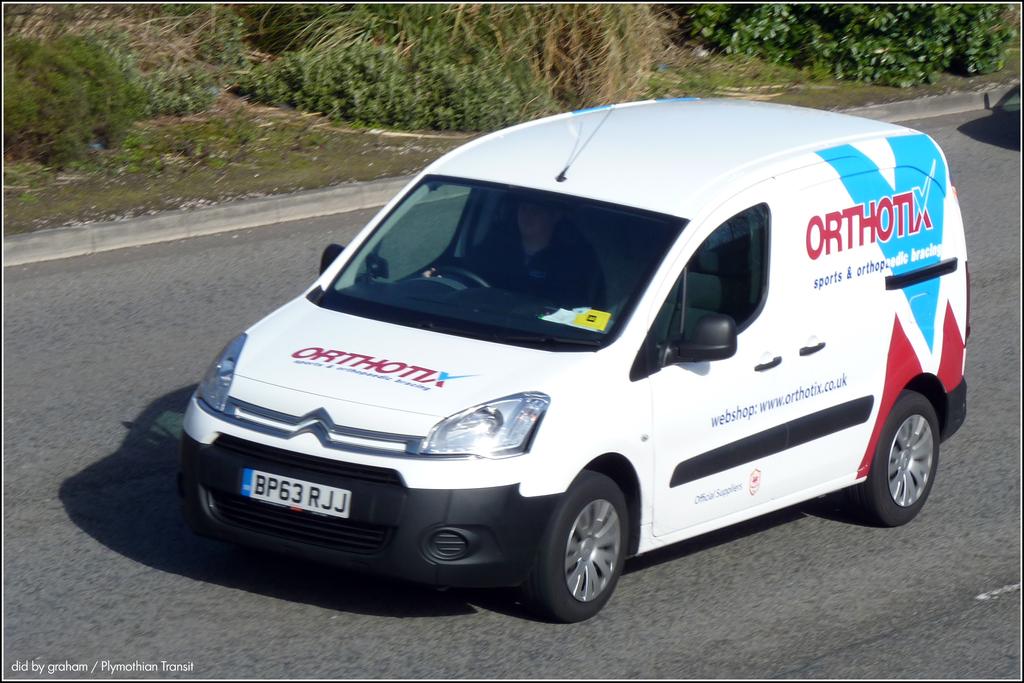What company does this van belong to?
Keep it short and to the point. Orthotix. 